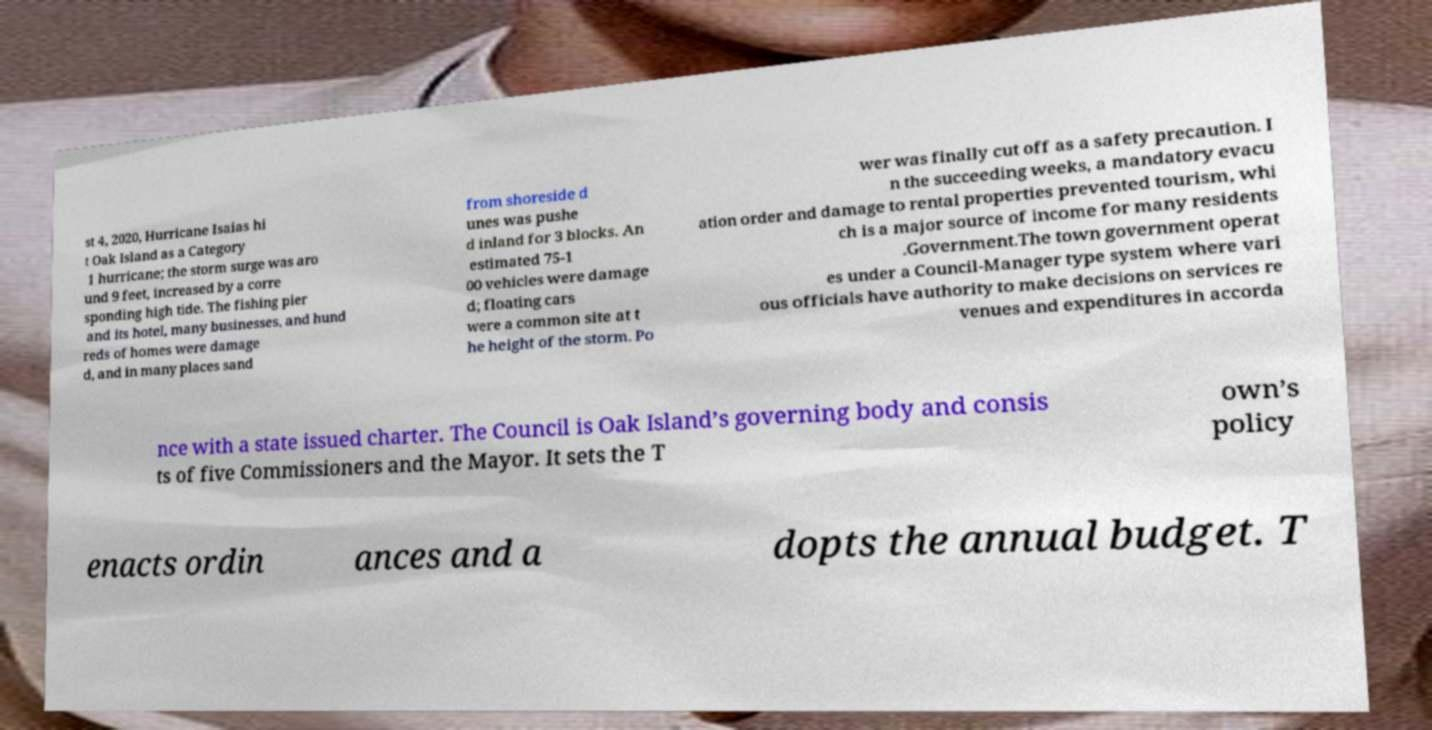Please read and relay the text visible in this image. What does it say? st 4, 2020, Hurricane Isaias hi t Oak Island as a Category 1 hurricane; the storm surge was aro und 9 feet, increased by a corre sponding high tide. The fishing pier and its hotel, many businesses, and hund reds of homes were damage d, and in many places sand from shoreside d unes was pushe d inland for 3 blocks. An estimated 75-1 00 vehicles were damage d; floating cars were a common site at t he height of the storm. Po wer was finally cut off as a safety precaution. I n the succeeding weeks, a mandatory evacu ation order and damage to rental properties prevented tourism, whi ch is a major source of income for many residents .Government.The town government operat es under a Council-Manager type system where vari ous officials have authority to make decisions on services re venues and expenditures in accorda nce with a state issued charter. The Council is Oak Island’s governing body and consis ts of five Commissioners and the Mayor. It sets the T own’s policy enacts ordin ances and a dopts the annual budget. T 